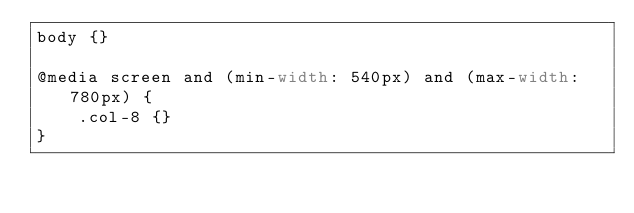<code> <loc_0><loc_0><loc_500><loc_500><_CSS_>body {}

@media screen and (min-width: 540px) and (max-width: 780px) {
    .col-8 {}
}</code> 